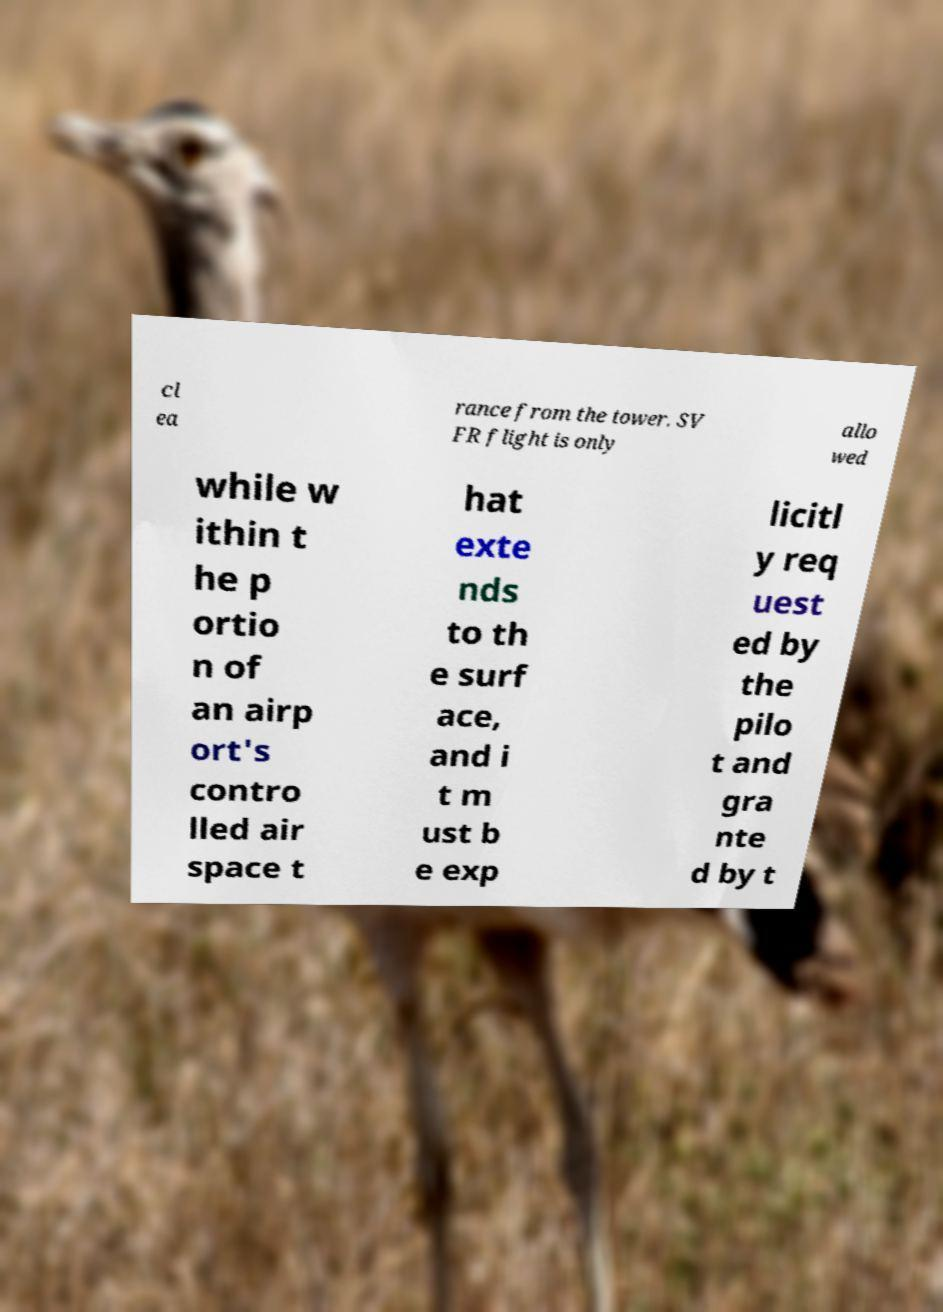Can you accurately transcribe the text from the provided image for me? cl ea rance from the tower. SV FR flight is only allo wed while w ithin t he p ortio n of an airp ort's contro lled air space t hat exte nds to th e surf ace, and i t m ust b e exp licitl y req uest ed by the pilo t and gra nte d by t 